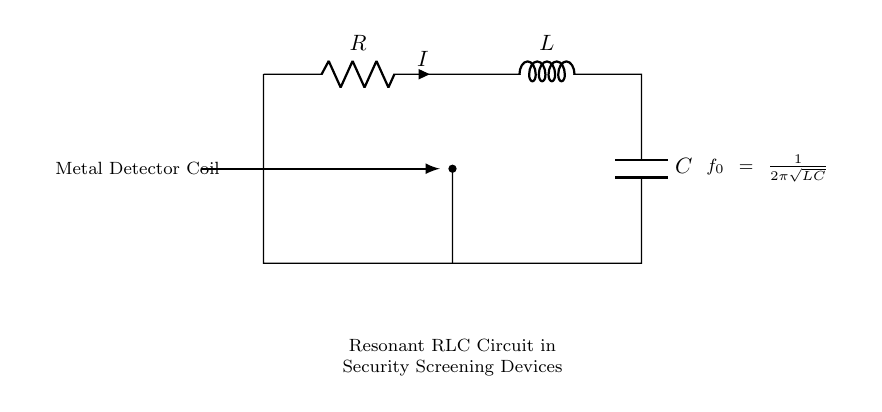What components are in this circuit? The circuit consists of a resistor, an inductor, and a capacitor. This is evident from the labels shown for each of the components in the diagram.
Answer: Resistor, inductor, capacitor What does the label "R" signify? The label "R" indicates the resistor in the circuit. This is a standard notation used in circuit diagrams to represent a resistor component.
Answer: Resistor What is the purpose of the inductor in this circuit? The inductor stores energy in a magnetic field when electrical current passes through it, which is important in controlling the current flow and oscillations in RLC circuits.
Answer: Store energy What is the formula for resonant frequency in this circuit? The formula presented in the diagram is f0 = 1/(2π√(LC)), where L represents inductance and C represents capacitance. This formula is essential to determine the frequency at which the circuit will resonate.
Answer: f0 = 1/(2π√(LC)) How does the resonant frequency affect the metal detector's performance? At the resonant frequency, the circuit has maximum impedance, which enhances its sensitivity to metallic objects, making the metal detector more effective in detecting the presence of metals.
Answer: Enhances sensitivity What happens to the circuit if either L or C is changed? Changing either the inductance (L) or capacitance (C) alters the resonant frequency according to the formula, which can significantly affect the circuit's behavior and its detection capability.
Answer: Alters resonant frequency 